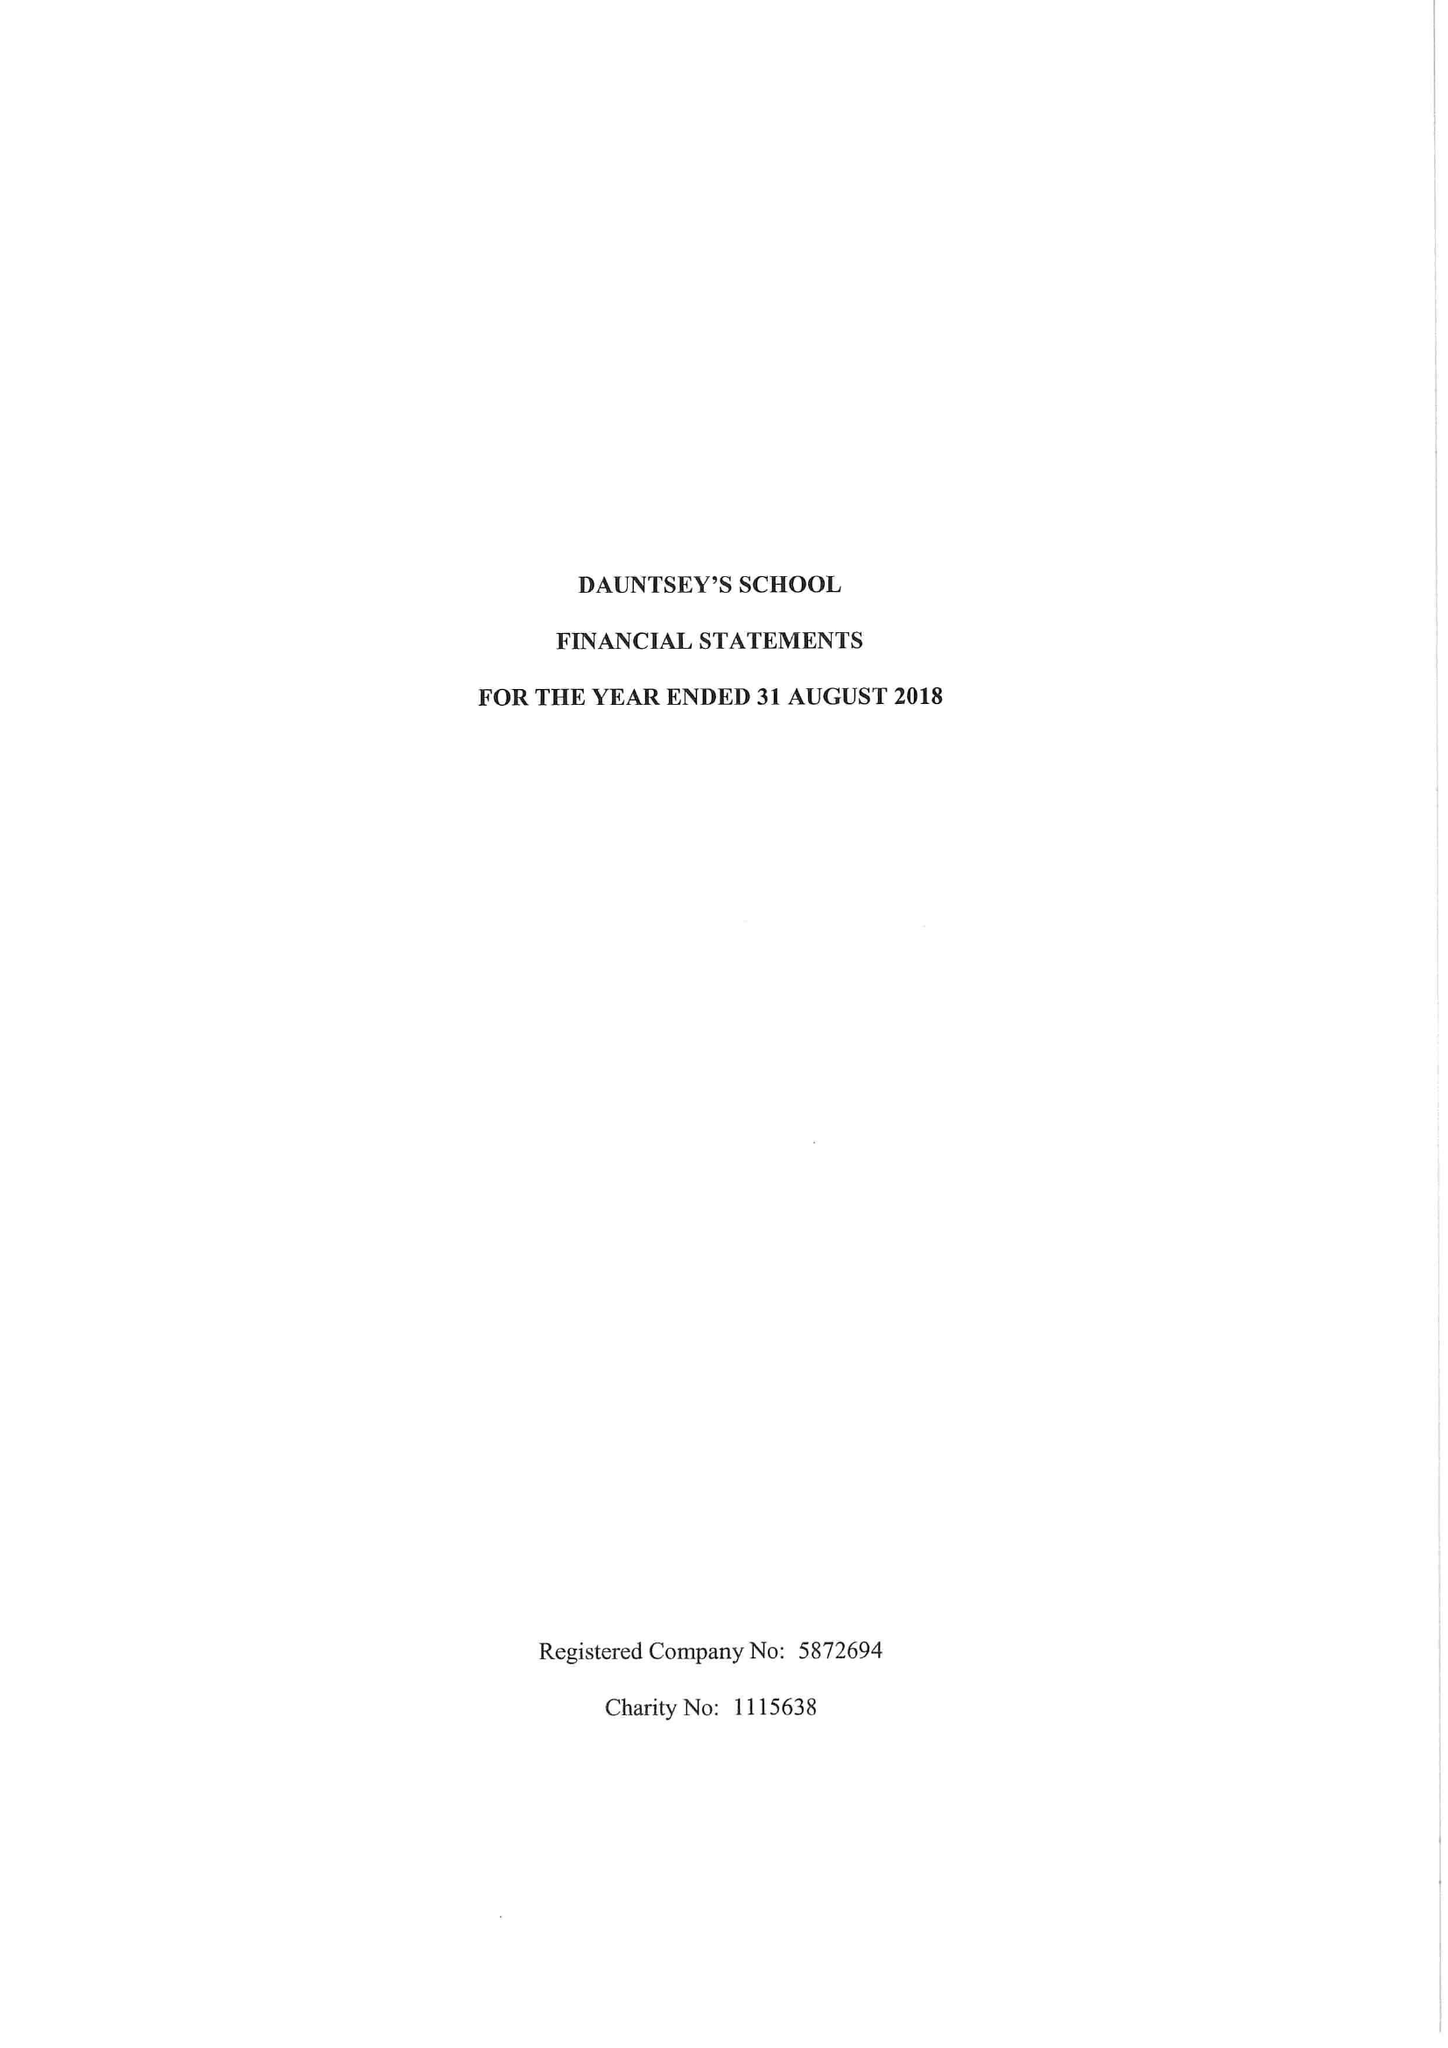What is the value for the charity_number?
Answer the question using a single word or phrase. 1115638 